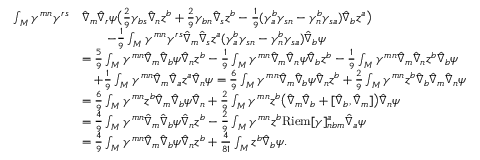<formula> <loc_0><loc_0><loc_500><loc_500>\begin{array} { r l } { \int _ { M } \gamma ^ { m n } \gamma ^ { r s } } & { \hat { \nabla } _ { m } \hat { \nabla } _ { r } \psi \left ( \frac { 2 } { 9 } \gamma _ { b s } \hat { \nabla } _ { n } z ^ { b } + \frac { 2 } { 9 } \gamma _ { b n } \hat { \nabla } _ { s } z ^ { b } - \frac { 1 } { 9 } ( \gamma ^ { b } _ { a } \gamma _ { s n } - \gamma ^ { b } _ { n } \gamma _ { s a } ) \hat { \nabla } _ { b } z ^ { a } \right ) } \\ & { \quad - \frac { 1 } { 9 } \int _ { M } \gamma ^ { m n } \gamma ^ { r s } \hat { \nabla } _ { m } \hat { \nabla } _ { s } z ^ { a } ( \gamma ^ { b } _ { a } \gamma _ { s n } - \gamma ^ { b } _ { n } \gamma _ { s a } ) \hat { \nabla } _ { b } \psi } \\ & { = \frac { 5 } { 9 } \int _ { M } \gamma ^ { m n } \hat { \nabla } _ { m } \hat { \nabla } _ { b } \psi \hat { \nabla } _ { n } z ^ { b } - \frac { 1 } { 9 } \int _ { M } \gamma ^ { m n } \hat { \nabla } _ { m } \hat { \nabla } _ { n } \psi \hat { \nabla } _ { b } z ^ { b } - \frac { 1 } { 9 } \int _ { M } \gamma ^ { m n } \hat { \nabla } _ { m } \hat { \nabla } _ { n } z ^ { b } \hat { \nabla } _ { b } \psi } \\ & { \quad + \frac { 1 } { 9 } \int _ { M } \gamma ^ { m n } \hat { \nabla } _ { m } \hat { \nabla } _ { a } z ^ { a } \hat { \nabla } _ { n } \psi = \frac { 6 } { 9 } \int _ { M } \gamma ^ { m n } \hat { \nabla } _ { m } \hat { \nabla } _ { b } \psi \hat { \nabla } _ { n } z ^ { b } + \frac { 2 } { 9 } \int _ { M } \gamma ^ { m n } z ^ { b } \hat { \nabla } _ { b } \hat { \nabla } _ { m } \hat { \nabla } _ { n } \psi } \\ & { = \frac { 6 } { 9 } \int _ { M } \gamma ^ { m n } z ^ { b } \hat { \nabla } _ { m } \hat { \nabla } _ { b } \psi \hat { \nabla } _ { n } + \frac { 2 } { 9 } \int _ { M } \gamma ^ { m n } z ^ { b } \left ( \hat { \nabla } _ { m } \hat { \nabla } _ { b } + [ \hat { \nabla } _ { b } , \hat { \nabla } _ { m } ] \right ) \hat { \nabla } _ { n } \psi } \\ & { = \frac { 4 } { 9 } \int _ { M } \gamma ^ { m n } \hat { \nabla } _ { m } \hat { \nabla } _ { b } \psi \hat { \nabla } _ { n } z ^ { b } - \frac { 2 } { 9 } \int _ { M } \gamma ^ { m n } z ^ { b } R i e m [ \gamma ] ^ { a } _ { n b m } \hat { \nabla } _ { a } \psi } \\ & { = \frac { 4 } { 9 } \int _ { M } \gamma ^ { m n } \hat { \nabla } _ { m } \hat { \nabla } _ { b } \psi \hat { \nabla } _ { n } z ^ { b } + \frac { 4 } { 8 1 } \int _ { M } z ^ { b } \hat { \nabla } _ { b } \psi . } \end{array}</formula> 